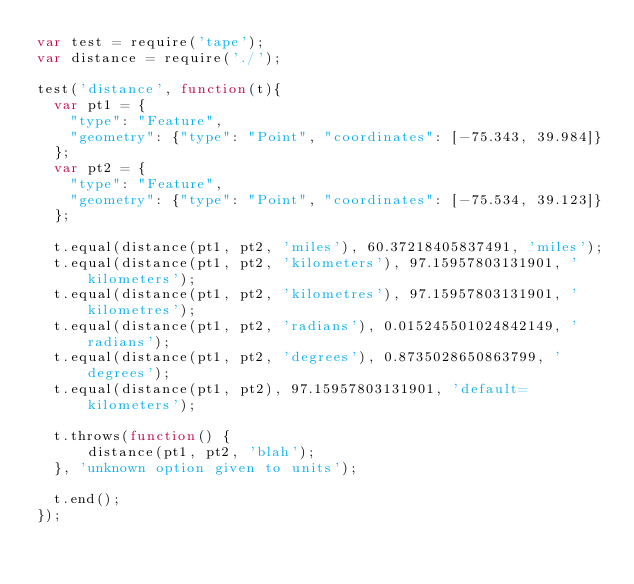<code> <loc_0><loc_0><loc_500><loc_500><_JavaScript_>var test = require('tape');
var distance = require('./');

test('distance', function(t){
  var pt1 = {
    "type": "Feature",
    "geometry": {"type": "Point", "coordinates": [-75.343, 39.984]}
  };
  var pt2 = {
    "type": "Feature",
    "geometry": {"type": "Point", "coordinates": [-75.534, 39.123]}
  };

  t.equal(distance(pt1, pt2, 'miles'), 60.37218405837491, 'miles');
  t.equal(distance(pt1, pt2, 'kilometers'), 97.15957803131901, 'kilometers');
  t.equal(distance(pt1, pt2, 'kilometres'), 97.15957803131901, 'kilometres');
  t.equal(distance(pt1, pt2, 'radians'), 0.015245501024842149, 'radians');
  t.equal(distance(pt1, pt2, 'degrees'), 0.8735028650863799, 'degrees');
  t.equal(distance(pt1, pt2), 97.15957803131901, 'default=kilometers');

  t.throws(function() {
      distance(pt1, pt2, 'blah');
  }, 'unknown option given to units');

  t.end();
});
</code> 